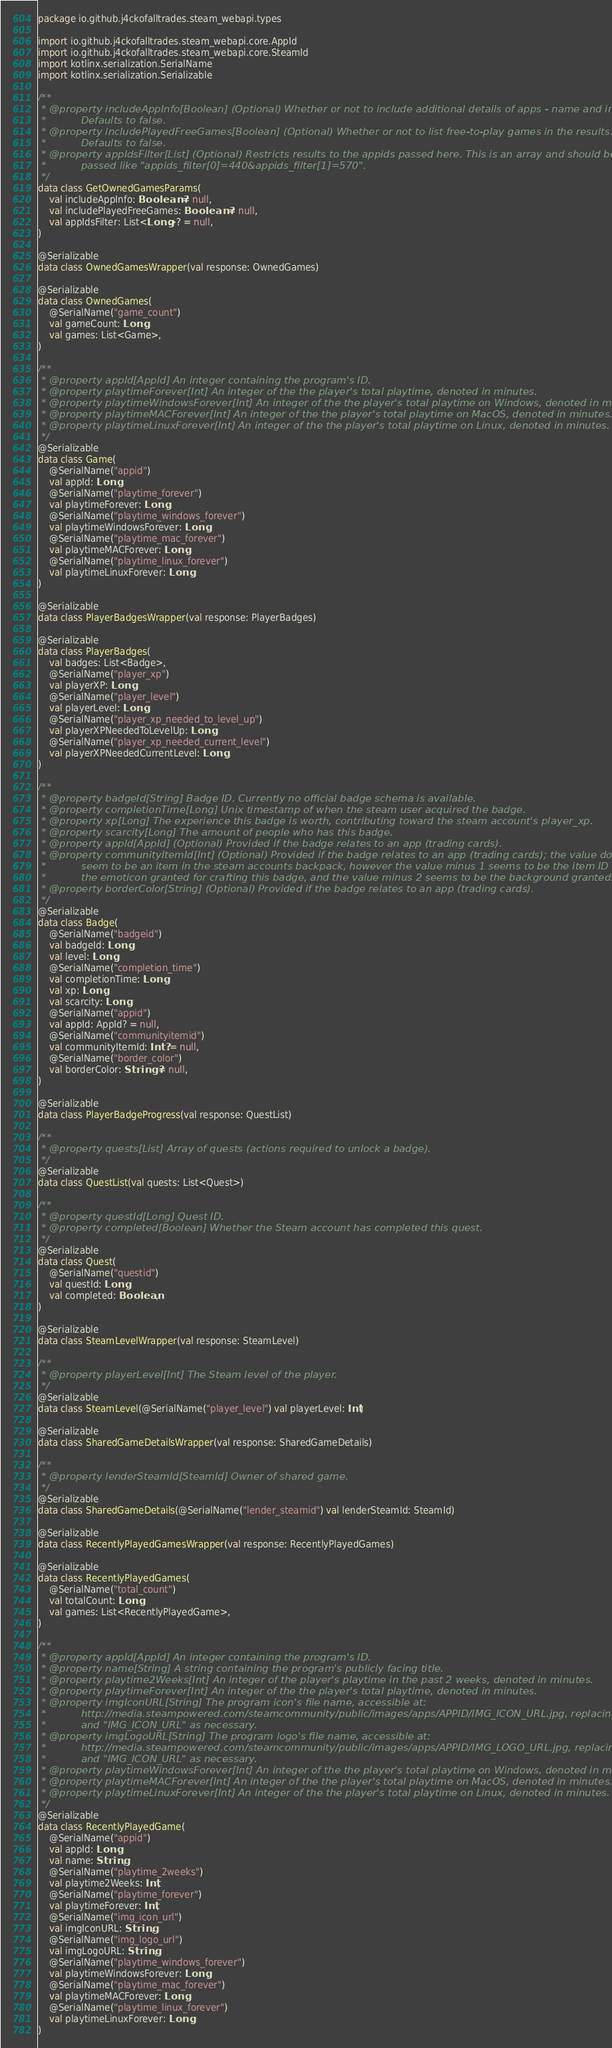Convert code to text. <code><loc_0><loc_0><loc_500><loc_500><_Kotlin_>package io.github.j4ckofalltrades.steam_webapi.types

import io.github.j4ckofalltrades.steam_webapi.core.AppId
import io.github.j4ckofalltrades.steam_webapi.core.SteamId
import kotlinx.serialization.SerialName
import kotlinx.serialization.Serializable

/**
 * @property includeAppInfo[Boolean] (Optional) Whether or not to include additional details of apps - name and images.
 *           Defaults to false.
 * @property includePlayedFreeGames[Boolean] (Optional) Whether or not to list free-to-play games in the results.
 *           Defaults to false.
 * @property appIdsFilter[List] (Optional) Restricts results to the appids passed here. This is an array and should be
 *           passed like "appids_filter[0]=440&appids_filter[1]=570".
 */
data class GetOwnedGamesParams(
    val includeAppInfo: Boolean? = null,
    val includePlayedFreeGames: Boolean? = null,
    val appIdsFilter: List<Long>? = null,
)

@Serializable
data class OwnedGamesWrapper(val response: OwnedGames)

@Serializable
data class OwnedGames(
    @SerialName("game_count")
    val gameCount: Long,
    val games: List<Game>,
)

/**
 * @property appId[AppId] An integer containing the program's ID.
 * @property playtimeForever[Int] An integer of the the player's total playtime, denoted in minutes.
 * @property playtimeWindowsForever[Int] An integer of the the player's total playtime on Windows, denoted in minutes.
 * @property playtimeMACForever[Int] An integer of the the player's total playtime on MacOS, denoted in minutes.
 * @property playtimeLinuxForever[Int] An integer of the the player's total playtime on Linux, denoted in minutes.
 */
@Serializable
data class Game(
    @SerialName("appid")
    val appId: Long,
    @SerialName("playtime_forever")
    val playtimeForever: Long,
    @SerialName("playtime_windows_forever")
    val playtimeWindowsForever: Long,
    @SerialName("playtime_mac_forever")
    val playtimeMACForever: Long,
    @SerialName("playtime_linux_forever")
    val playtimeLinuxForever: Long,
)

@Serializable
data class PlayerBadgesWrapper(val response: PlayerBadges)

@Serializable
data class PlayerBadges(
    val badges: List<Badge>,
    @SerialName("player_xp")
    val playerXP: Long,
    @SerialName("player_level")
    val playerLevel: Long,
    @SerialName("player_xp_needed_to_level_up")
    val playerXPNeededToLevelUp: Long,
    @SerialName("player_xp_needed_current_level")
    val playerXPNeededCurrentLevel: Long,
)

/**
 * @property badgeId[String] Badge ID. Currently no official badge schema is available.
 * @property completionTime[Long] Unix timestamp of when the steam user acquired the badge.
 * @property xp[Long] The experience this badge is worth, contributing toward the steam account's player_xp.
 * @property scarcity[Long] The amount of people who has this badge.
 * @property appId[AppId] (Optional) Provided if the badge relates to an app (trading cards).
 * @property communityItemId[Int] (Optional) Provided if the badge relates to an app (trading cards); the value doesn't
 *           seem to be an item in the steam accounts backpack, however the value minus 1 seems to be the item ID for
 *           the emoticon granted for crafting this badge, and the value minus 2 seems to be the background granted.
 * @property borderColor[String] (Optional) Provided if the badge relates to an app (trading cards).
 */
@Serializable
data class Badge(
    @SerialName("badgeid")
    val badgeId: Long,
    val level: Long,
    @SerialName("completion_time")
    val completionTime: Long,
    val xp: Long,
    val scarcity: Long,
    @SerialName("appid")
    val appId: AppId? = null,
    @SerialName("communityitemid")
    val communityItemId: Int? = null,
    @SerialName("border_color")
    val borderColor: String? = null,
)

@Serializable
data class PlayerBadgeProgress(val response: QuestList)

/**
 * @property quests[List] Array of quests (actions required to unlock a badge).
 */
@Serializable
data class QuestList(val quests: List<Quest>)

/**
 * @property questId[Long] Quest ID.
 * @property completed[Boolean] Whether the Steam account has completed this quest.
 */
@Serializable
data class Quest(
    @SerialName("questid")
    val questId: Long,
    val completed: Boolean,
)

@Serializable
data class SteamLevelWrapper(val response: SteamLevel)

/**
 * @property playerLevel[Int] The Steam level of the player.
 */
@Serializable
data class SteamLevel(@SerialName("player_level") val playerLevel: Int)

@Serializable
data class SharedGameDetailsWrapper(val response: SharedGameDetails)

/**
 * @property lenderSteamId[SteamId] Owner of shared game.
 */
@Serializable
data class SharedGameDetails(@SerialName("lender_steamid") val lenderSteamId: SteamId)

@Serializable
data class RecentlyPlayedGamesWrapper(val response: RecentlyPlayedGames)

@Serializable
data class RecentlyPlayedGames(
    @SerialName("total_count")
    val totalCount: Long,
    val games: List<RecentlyPlayedGame>,
)

/**
 * @property appId[AppId] An integer containing the program's ID.
 * @property name[String] A string containing the program's publicly facing title.
 * @property playtime2Weeks[Int] An integer of the player's playtime in the past 2 weeks, denoted in minutes.
 * @property playtimeForever[Int] An integer of the the player's total playtime, denoted in minutes.
 * @property imgIconURL[String] The program icon's file name, accessible at:
 *           http://media.steampowered.com/steamcommunity/public/images/apps/APPID/IMG_ICON_URL.jpg, replacing "APPID"
 *           and "IMG_ICON_URL" as necessary.
 * @property imgLogoURL[String] The program logo's file name, accessible at:
 *           http://media.steampowered.com/steamcommunity/public/images/apps/APPID/IMG_LOGO_URL.jpg, replacing "APPID"
 *           and "IMG_ICON_URL" as necessary.
 * @property playtimeWindowsForever[Int] An integer of the the player's total playtime on Windows, denoted in minutes.
 * @property playtimeMACForever[Int] An integer of the the player's total playtime on MacOS, denoted in minutes.
 * @property playtimeLinuxForever[Int] An integer of the the player's total playtime on Linux, denoted in minutes.
 */
@Serializable
data class RecentlyPlayedGame(
    @SerialName("appid")
    val appId: Long,
    val name: String,
    @SerialName("playtime_2weeks")
    val playtime2Weeks: Int,
    @SerialName("playtime_forever")
    val playtimeForever: Int,
    @SerialName("img_icon_url")
    val imgIconURL: String,
    @SerialName("img_logo_url")
    val imgLogoURL: String,
    @SerialName("playtime_windows_forever")
    val playtimeWindowsForever: Long,
    @SerialName("playtime_mac_forever")
    val playtimeMACForever: Long,
    @SerialName("playtime_linux_forever")
    val playtimeLinuxForever: Long,
)
</code> 